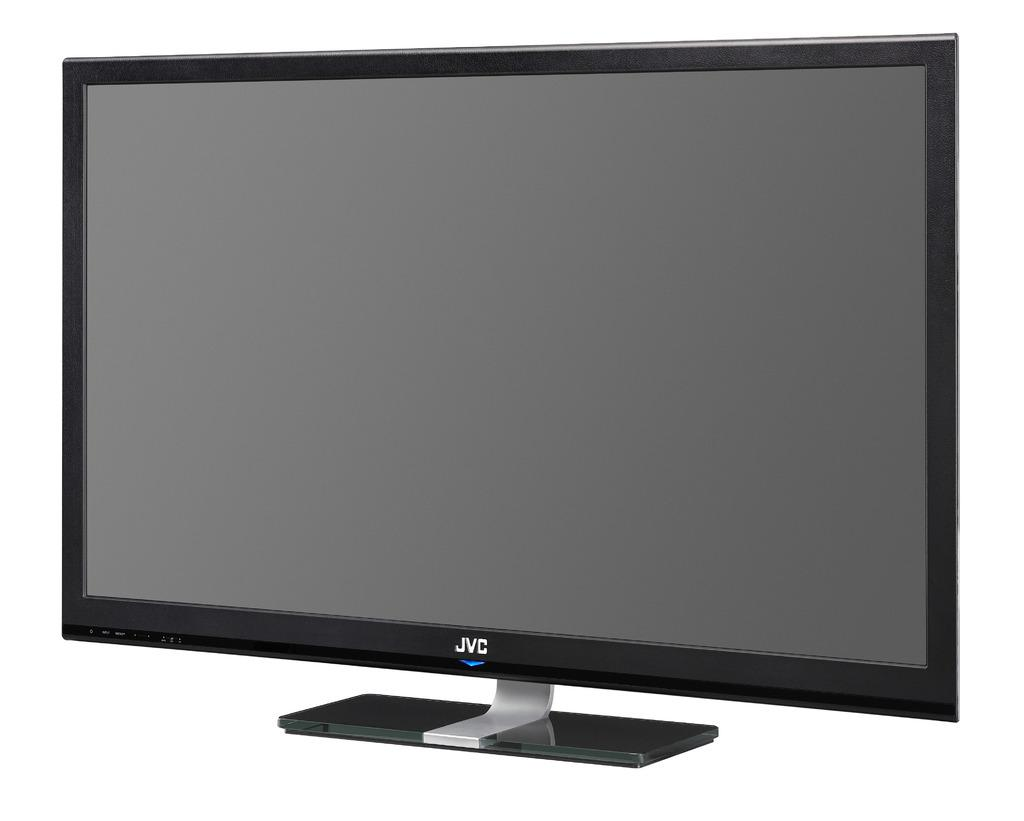<image>
Give a short and clear explanation of the subsequent image. A picture of a JVC flat screen TV. 